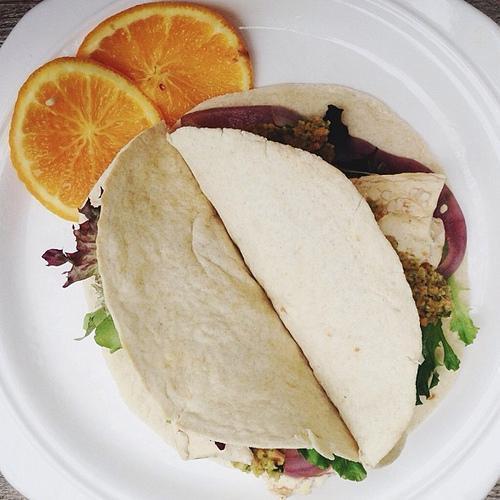How many sandwich halves are shown?
Give a very brief answer. 2. 